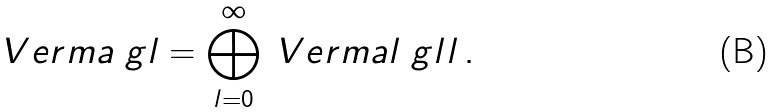Convert formula to latex. <formula><loc_0><loc_0><loc_500><loc_500>\ V e r m a { \ g l } = \bigoplus _ { l = 0 } ^ { \infty } \ V e r m a l { \ g l } { l } \, .</formula> 